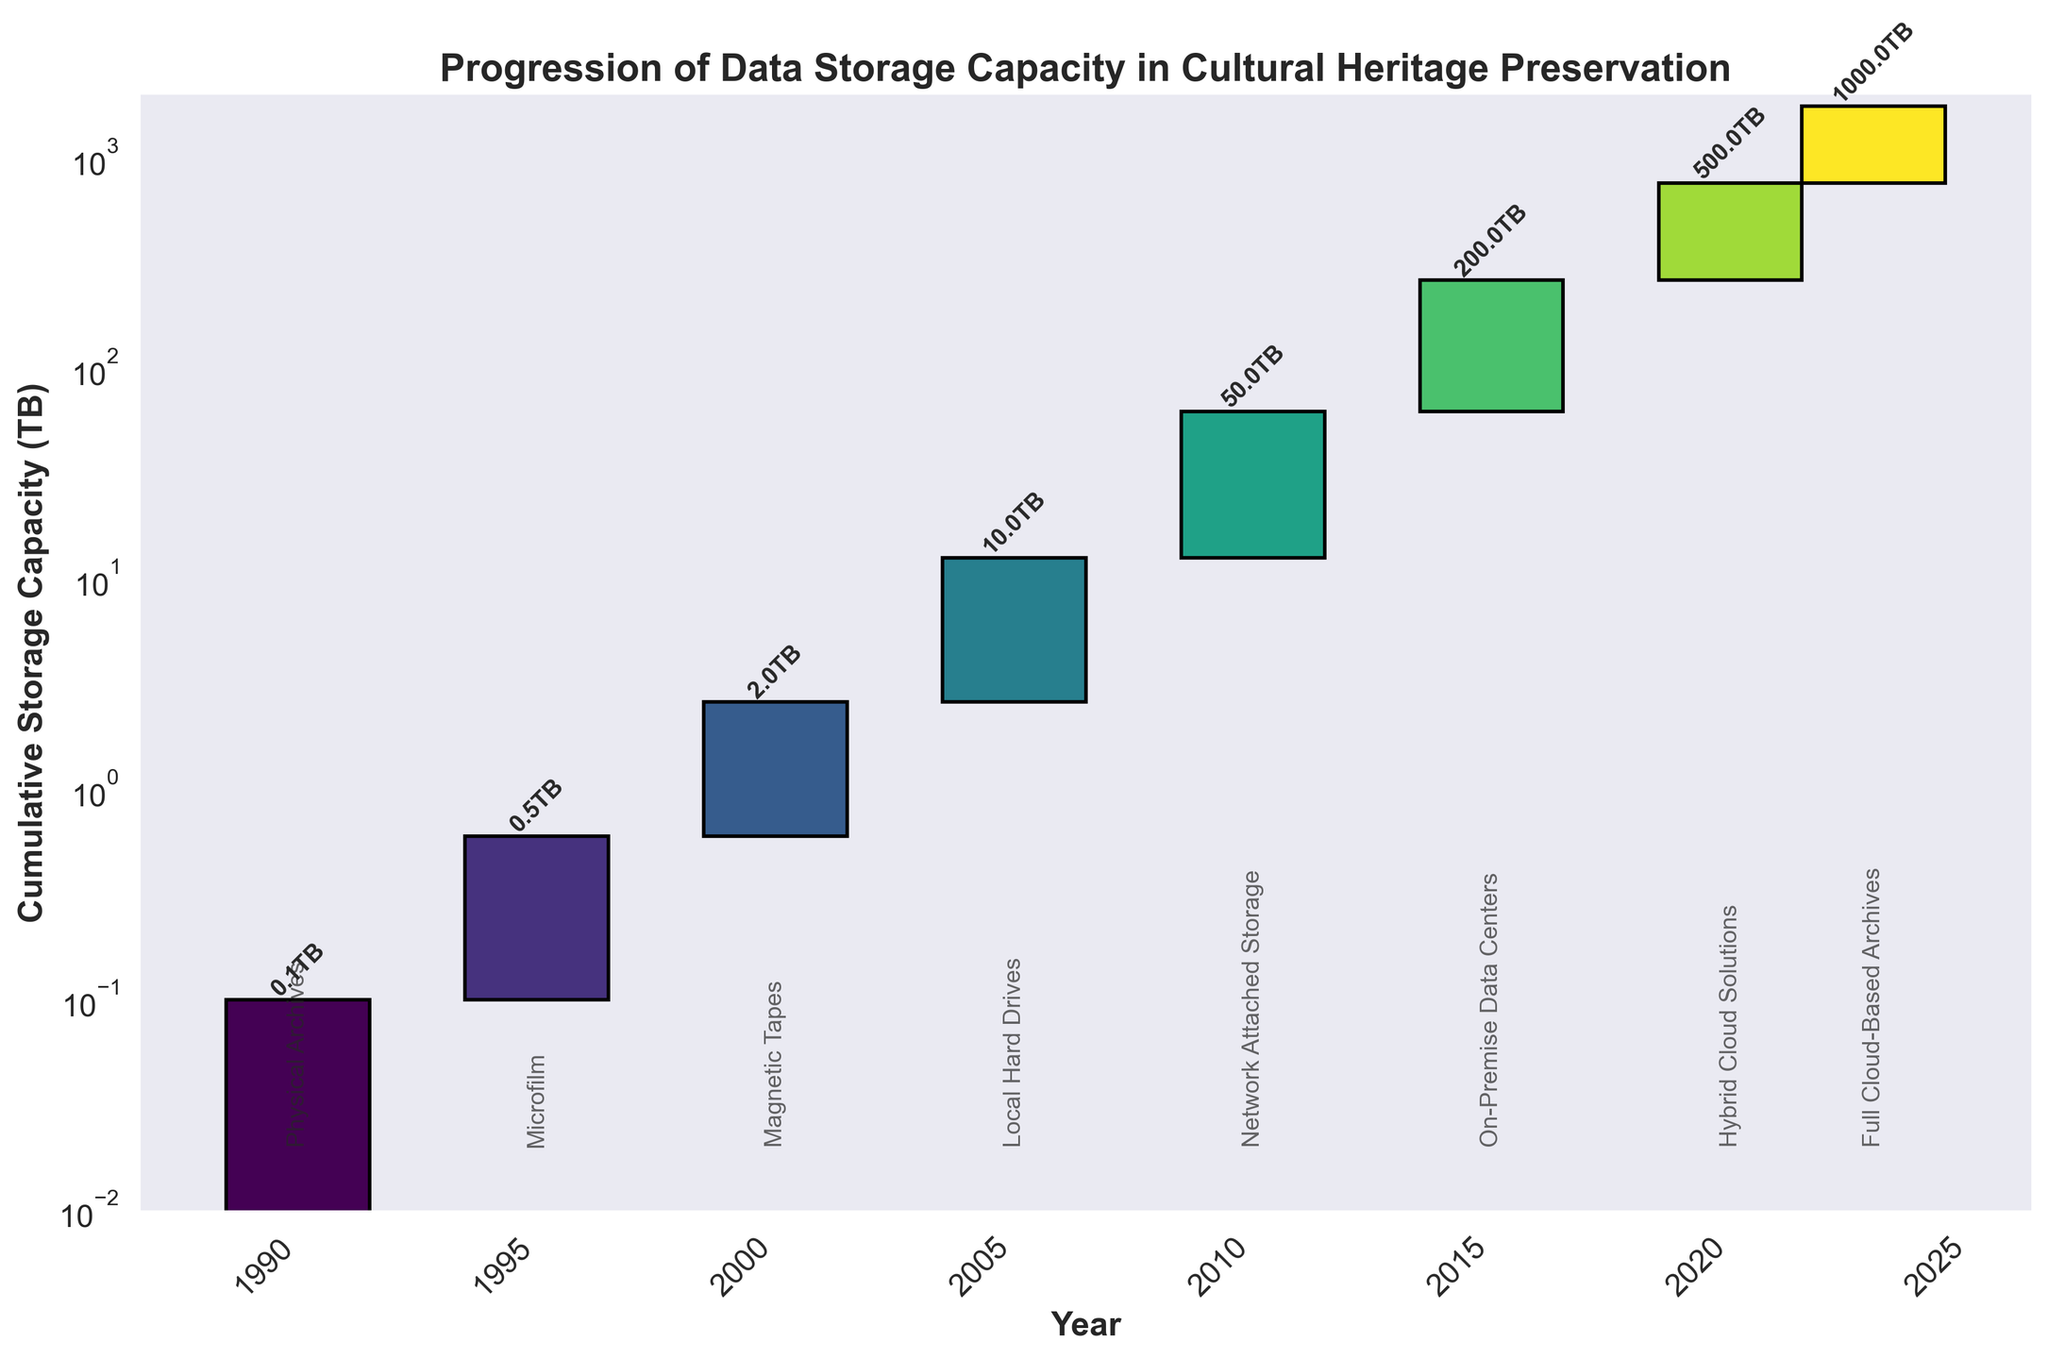What is the title of the figure? The title is the large, bold text at the top of the figure that indicates the main subject of the chart.
Answer: Progression of Data Storage Capacity in Cultural Heritage Preservation How many different storage types are represented in the chart? The chart has separate bars for each storage type, which are annotated at the base of each bar. Count these annotations.
Answer: 8 What storage type was used in 2000, and what was the change in storage capacity that year? Look for the bar corresponding to the year 2000 and identify the storage type annotation and the label indicating the change in capacity for that year.
Answer: Magnetic Tapes, 2TB Which year saw the largest increase in storage capacity? Compare the height of the bars across all years to identify the tallest bar, which represents the largest increase in storage capacity.
Answer: 2023 What is the cumulative storage capacity by the year 2015? Sum the capacity changes from all preceding years up to 2015 and include the capacity change for 2015. The cumulative values can often be seen at the top of each bar.
Answer: 263.6TB Compare the increase in storage capacity from 2010 to 2015 with the increase from 2015 to 2020. Which period saw a larger increase? Find the capacity changes for both periods by subtracting the cumulative value of the start year from the end year for both periods and then compare these values.
Answer: 2015 to 2020 What is the difference in storage capacity change between Local Hard Drives (2005) and On-Premise Data Centers (2015)? Find the capacity change values for both years and subtract the smaller value from the larger one to find the difference.
Answer: 190TB What is the cumulative storage capacity in 2020? Look for the bar corresponding to the year 2020 and read the value at the top of the bar, which represents the cumulative capacity up to that year.
Answer: 763.6TB How does the cumulative storage capacity in 1995 compare to that in 2023? Compare the cumulative values at the top of the bars for the years 1995 and 2023 directly.
Answer: 0.5TB in 1995 vs 1763.6TB in 2023 What storage type saw the smallest change in storage capacity, and what was the capacity change? Find the bar with the smallest height and identify the storage type annotation and its capacity change label.
Answer: Physical Archives, 0.1TB 